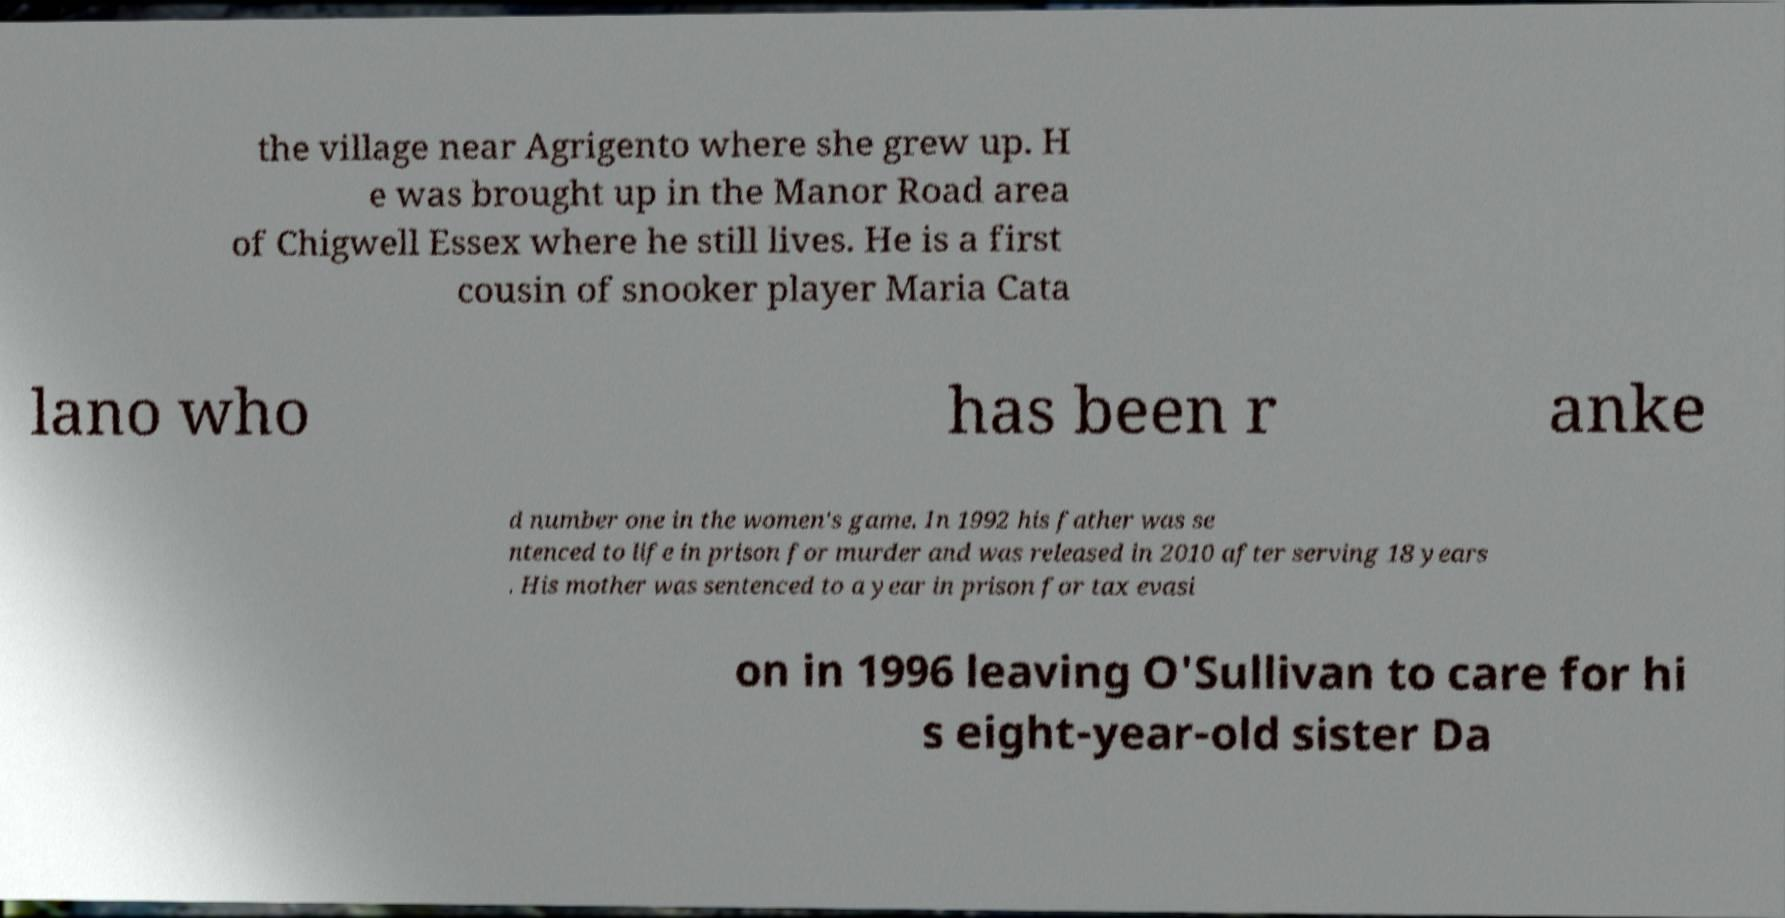Can you read and provide the text displayed in the image?This photo seems to have some interesting text. Can you extract and type it out for me? the village near Agrigento where she grew up. H e was brought up in the Manor Road area of Chigwell Essex where he still lives. He is a first cousin of snooker player Maria Cata lano who has been r anke d number one in the women's game. In 1992 his father was se ntenced to life in prison for murder and was released in 2010 after serving 18 years . His mother was sentenced to a year in prison for tax evasi on in 1996 leaving O'Sullivan to care for hi s eight-year-old sister Da 